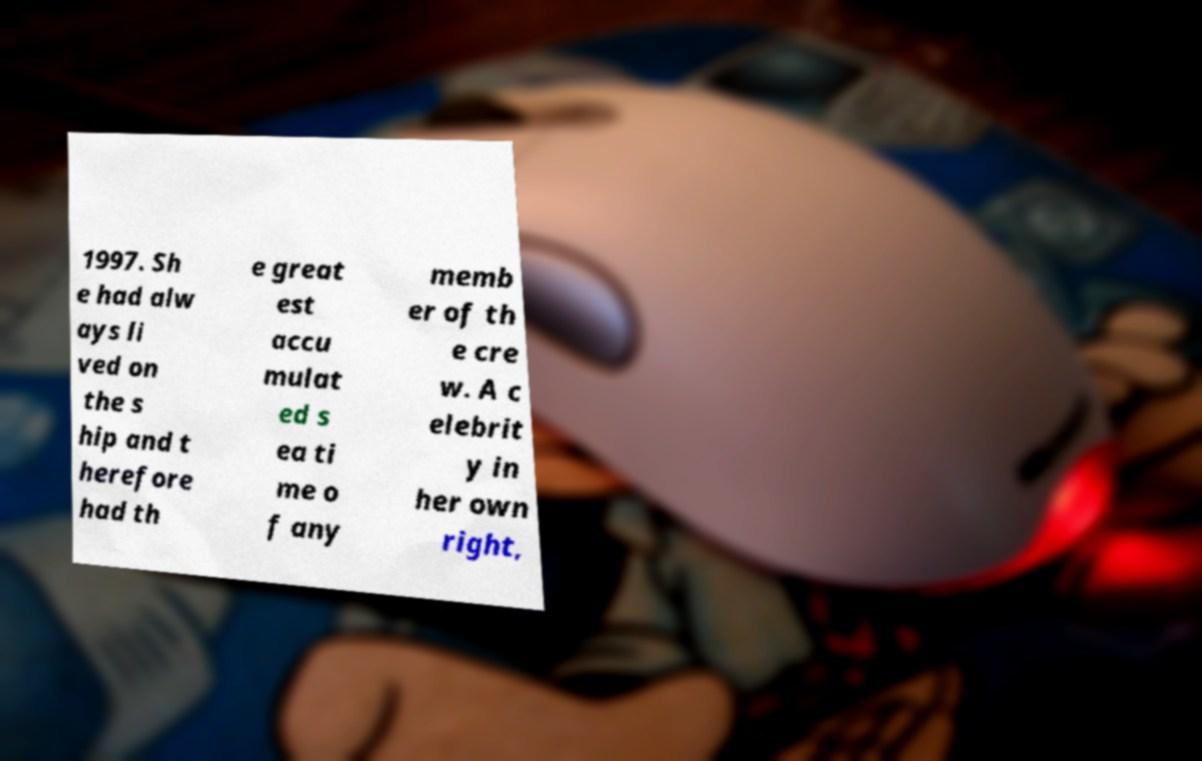What messages or text are displayed in this image? I need them in a readable, typed format. 1997. Sh e had alw ays li ved on the s hip and t herefore had th e great est accu mulat ed s ea ti me o f any memb er of th e cre w. A c elebrit y in her own right, 